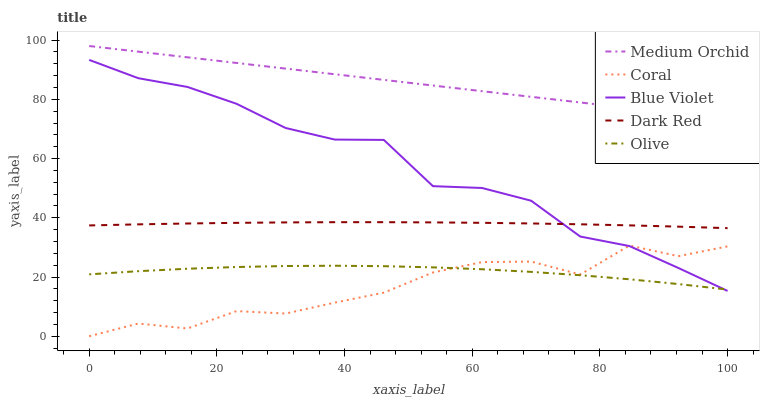Does Coral have the minimum area under the curve?
Answer yes or no. Yes. Does Medium Orchid have the maximum area under the curve?
Answer yes or no. Yes. Does Dark Red have the minimum area under the curve?
Answer yes or no. No. Does Dark Red have the maximum area under the curve?
Answer yes or no. No. Is Medium Orchid the smoothest?
Answer yes or no. Yes. Is Coral the roughest?
Answer yes or no. Yes. Is Dark Red the smoothest?
Answer yes or no. No. Is Dark Red the roughest?
Answer yes or no. No. Does Coral have the lowest value?
Answer yes or no. Yes. Does Dark Red have the lowest value?
Answer yes or no. No. Does Medium Orchid have the highest value?
Answer yes or no. Yes. Does Dark Red have the highest value?
Answer yes or no. No. Is Coral less than Dark Red?
Answer yes or no. Yes. Is Dark Red greater than Olive?
Answer yes or no. Yes. Does Coral intersect Blue Violet?
Answer yes or no. Yes. Is Coral less than Blue Violet?
Answer yes or no. No. Is Coral greater than Blue Violet?
Answer yes or no. No. Does Coral intersect Dark Red?
Answer yes or no. No. 